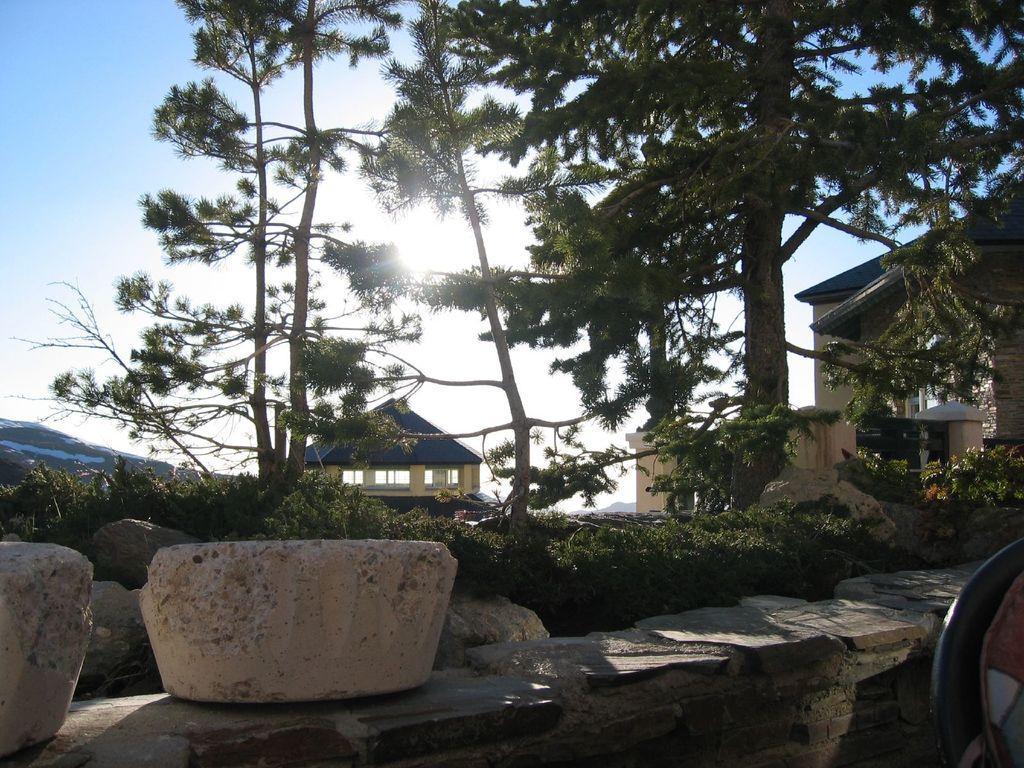What type of natural elements can be seen in the image? There are trees in the image. What type of man-made structures are present in the image? There are houses in the image. What type of material is present in the image? There are stones in the image. What type of barrier can be seen in the image? There is a wall in the image. What is visible in the background of the image? The sky is visible in the background of the image. What type of music can be heard coming from the kitten in the image? There is no kitten present in the image, and therefore no music can be heard. What is located in the middle of the image? The provided facts do not specify any particular object or subject being located in the middle of the image. 